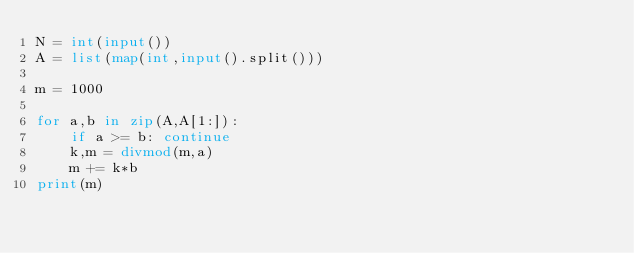<code> <loc_0><loc_0><loc_500><loc_500><_Python_>N = int(input())
A = list(map(int,input().split()))

m = 1000

for a,b in zip(A,A[1:]):
    if a >= b: continue
    k,m = divmod(m,a)
    m += k*b
print(m)</code> 